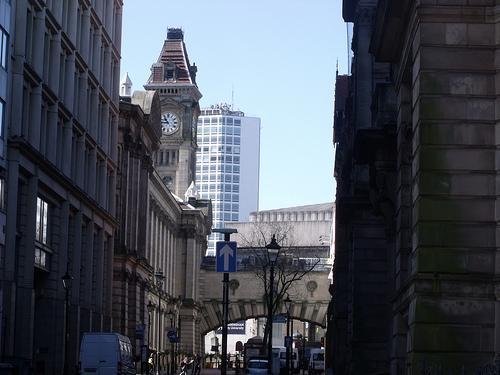How many clocks are there?
Give a very brief answer. 1. 